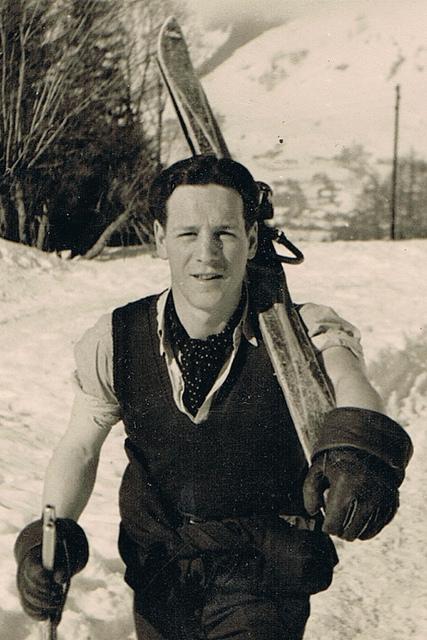Is he wearing gloves?
Concise answer only. Yes. Is it snowing?
Keep it brief. No. What sport does this man partake in?
Keep it brief. Skiing. 